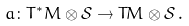<formula> <loc_0><loc_0><loc_500><loc_500>a \colon T ^ { * } M \otimes \mathcal { S } \to T M \otimes \mathcal { S } \, .</formula> 